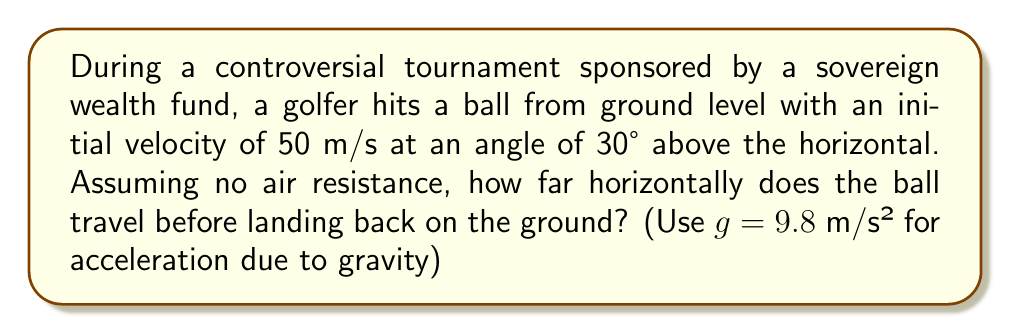Help me with this question. Let's approach this step-by-step using the parabolic equation for projectile motion:

1) The horizontal and vertical components of the initial velocity are:
   $v_x = v \cos \theta = 50 \cos 30° = 43.3$ m/s
   $v_y = v \sin \theta = 50 \sin 30° = 25$ m/s

2) The time of flight can be calculated using the equation:
   $y = v_y t - \frac{1}{2}gt^2$
   
   At the highest point, $y = 0$:
   $0 = 25t - 4.9t^2$
   $t = \frac{25}{4.9} = 5.1$ seconds (for half the flight)

3) Total time of flight = $2 \times 5.1 = 10.2$ seconds

4) The horizontal distance traveled is:
   $x = v_x \times \text{total time}$
   $x = 43.3 \times 10.2 = 441.66$ meters

To visualize:

[asy]
import graph;
size(200,150);
real f(real x) {return -0.0022*x*x + 0.5774*x;}
draw(graph(f,0,441.66));
draw((0,0)--(441.66,0),arrow=Arrow(TeXHead));
draw((0,0)--(0,100),arrow=Arrow(TeXHead));
label("x (m)",(441.66,0),S);
label("y (m)",(0,100),W);
label("Trajectory",(200,80),N);
[/asy]
Answer: 441.66 m 